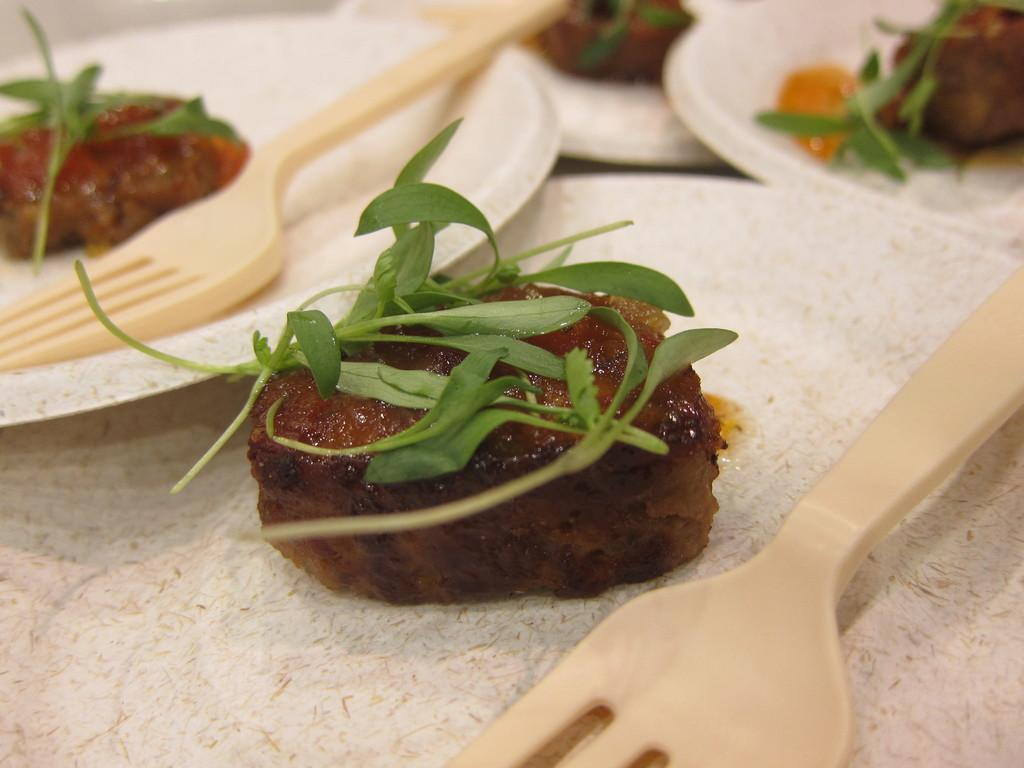What objects are present on the plates in the image? The plates contain forks. What is the purpose of the forks on the plates? The forks are likely used for eating the food on the plates. What can be observed on the food itself? There are leaves on the food. What type of blood is visible on the scene in the image? There is no blood visible in the image; it features plates with forks and food containing leaves. 